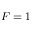<formula> <loc_0><loc_0><loc_500><loc_500>F = 1</formula> 